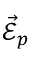<formula> <loc_0><loc_0><loc_500><loc_500>\vec { \mathcal { E } } _ { p }</formula> 